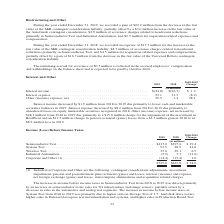According to Teradyne's financial document, What was the change in interest income in 2019? decreased by $1.9 million. The document states: "Interest income decreased by $1.9 million from 2018 to 2019 due primarily to lower cash and marketable securities balances in 2019. Interest..." Also, What was the change in interest expense in 2019? decreased by $8.2 million. The document states: "ble securities balances in 2019. Interest expense decreased by $8.2 million from 2018 to 2019 due primarily to unrealized losses on equity marketable ..." Also, What are the components analyzed under Interest and Other in the table? The document contains multiple relevant values: Interest income, Interest expense, Other (income) expense, net. From the document: "$(26.7) $ 1.9 Interest expense . 23.1 31.3 (8.2) Other (income) expense, net . 29.5 1.4 28.1 millions) Interest income . $(24.8) $(26.7) $ 1.9 Interes..." Additionally, In which year was interest expense larger? According to the financial document, 2018. The relevant text states: "During the year ended December 31, 2018, we recorded an expense of $17.7 million for the increase in the fair value of the MiR contingent c..." Also, can you calculate: What was the percentage change in Interest expense in 2019 from 2018? To answer this question, I need to perform calculations using the financial data. The calculation is: (23.1-31.3)/31.3, which equals -26.2 (percentage). This is based on the information: "e . $(24.8) $(26.7) $ 1.9 Interest expense . 23.1 31.3 (8.2) Other (income) expense, net . 29.5 1.4 28.1 income . $(24.8) $(26.7) $ 1.9 Interest expense . 23.1 31.3 (8.2) Other (income) expense, net ...." The key data points involved are: 23.1, 31.3. Also, can you calculate: What was the percentage change in Other (income) expense, net in 2019 from 2018? To answer this question, I need to perform calculations using the financial data. The calculation is: (29.5-1.4)/1.4, which equals 2007.14 (percentage). This is based on the information: "e . 23.1 31.3 (8.2) Other (income) expense, net . 29.5 1.4 28.1 3.1 31.3 (8.2) Other (income) expense, net . 29.5 1.4 28.1..." The key data points involved are: 1.4, 29.5. 